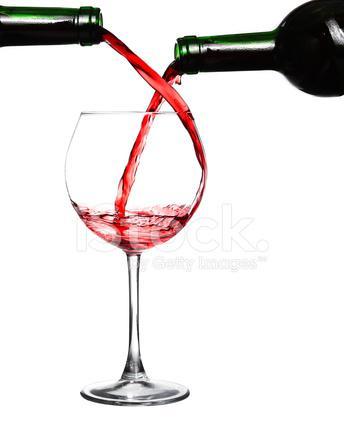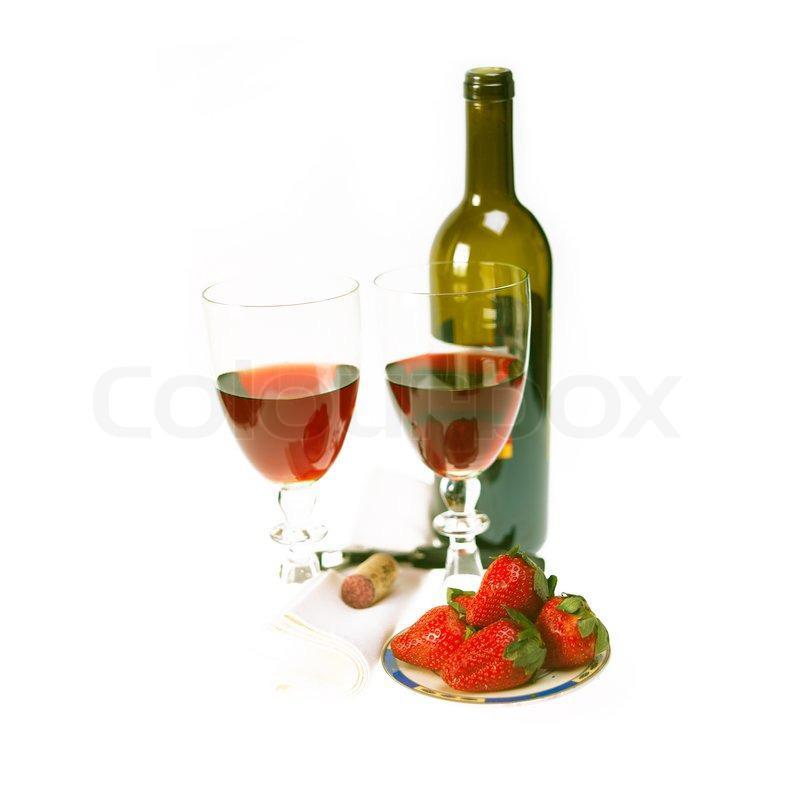The first image is the image on the left, the second image is the image on the right. Given the left and right images, does the statement "An image includes two glasses of wine, at least one bunch of grapes, and one wine bottle." hold true? Answer yes or no. No. The first image is the image on the left, the second image is the image on the right. Given the left and right images, does the statement "Wine is being poured in a wine glass in one of the images." hold true? Answer yes or no. Yes. 